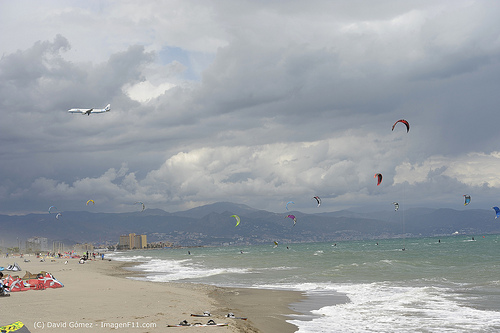Please provide a short description for this region: [0.05, 0.62, 0.33, 0.68]. The region with the bounding box coordinates [0.05, 0.62, 0.33, 0.68] features hotels on the ocean front. 